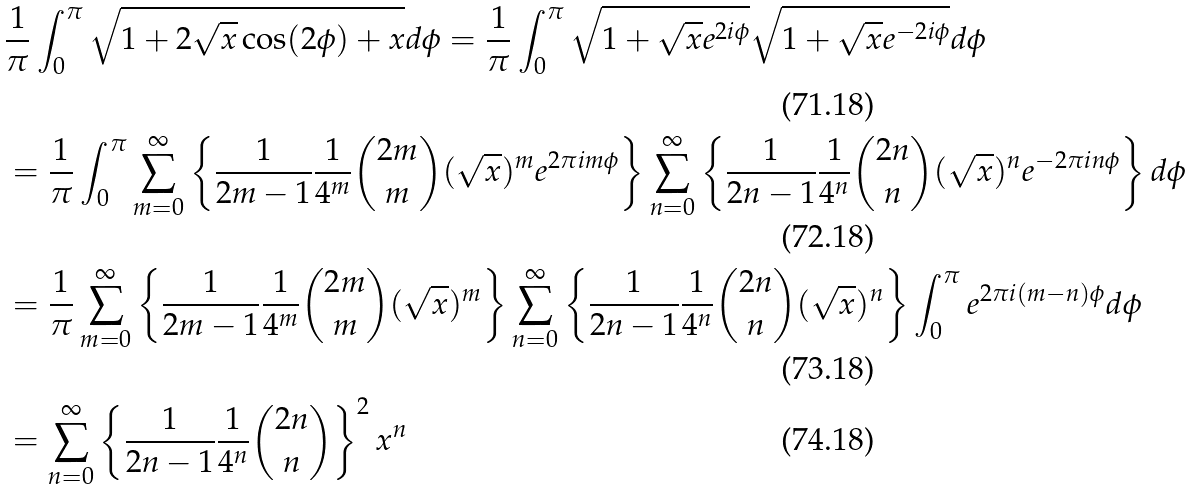<formula> <loc_0><loc_0><loc_500><loc_500>& \frac { 1 } { \pi } \int _ { 0 } ^ { \pi } \sqrt { 1 + 2 \sqrt { x } \cos ( 2 \phi ) + x } d \phi = \frac { 1 } { \pi } \int _ { 0 } ^ { \pi } \sqrt { 1 + \sqrt { x } e ^ { 2 i \phi } } \sqrt { 1 + \sqrt { x } e ^ { - 2 i \phi } } d \phi & \\ & = \frac { 1 } { \pi } \int _ { 0 } ^ { \pi } \sum _ { m = 0 } ^ { \infty } \left \{ \frac { 1 } { 2 m - 1 } \frac { 1 } { 4 ^ { m } } \binom { 2 m } { m } ( \sqrt { x } ) ^ { m } e ^ { 2 \pi i m \phi } \right \} \sum _ { n = 0 } ^ { \infty } \left \{ \frac { 1 } { 2 n - 1 } \frac { 1 } { 4 ^ { n } } \binom { 2 n } { n } ( \sqrt { x } ) ^ { n } e ^ { - 2 \pi i n \phi } \right \} d \phi \\ & = \frac { 1 } { \pi } \sum _ { m = 0 } ^ { \infty } \left \{ \frac { 1 } { 2 m - 1 } \frac { 1 } { 4 ^ { m } } \binom { 2 m } { m } ( \sqrt { x } ) ^ { m } \right \} \sum _ { n = 0 } ^ { \infty } \left \{ \frac { 1 } { 2 n - 1 } \frac { 1 } { 4 ^ { n } } \binom { 2 n } { n } ( \sqrt { x } ) ^ { n } \right \} \int _ { 0 } ^ { \pi } e ^ { 2 \pi i ( m - n ) \phi } d \phi \\ & = \sum _ { n = 0 } ^ { \infty } \left \{ \frac { 1 } { 2 n - 1 } \frac { 1 } { 4 ^ { n } } \binom { 2 n } { n } \right \} ^ { 2 } x ^ { n }</formula> 